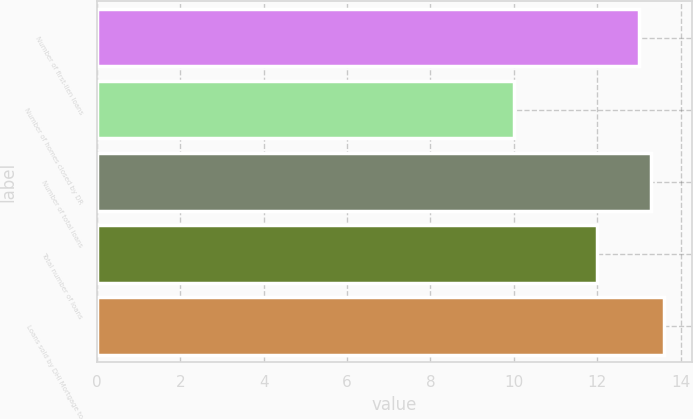Convert chart. <chart><loc_0><loc_0><loc_500><loc_500><bar_chart><fcel>Number of first-lien loans<fcel>Number of homes closed by DR<fcel>Number of total loans<fcel>Total number of loans<fcel>Loans sold by DHI Mortgage to<nl><fcel>13<fcel>10<fcel>13.3<fcel>12<fcel>13.6<nl></chart> 